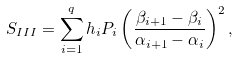Convert formula to latex. <formula><loc_0><loc_0><loc_500><loc_500>S _ { I I I } = \sum _ { i = 1 } ^ { q } h _ { i } P _ { i } \left ( \frac { \beta _ { i + 1 } - \beta _ { i } } { \alpha _ { i + 1 } - \alpha _ { i } } \right ) ^ { 2 } ,</formula> 